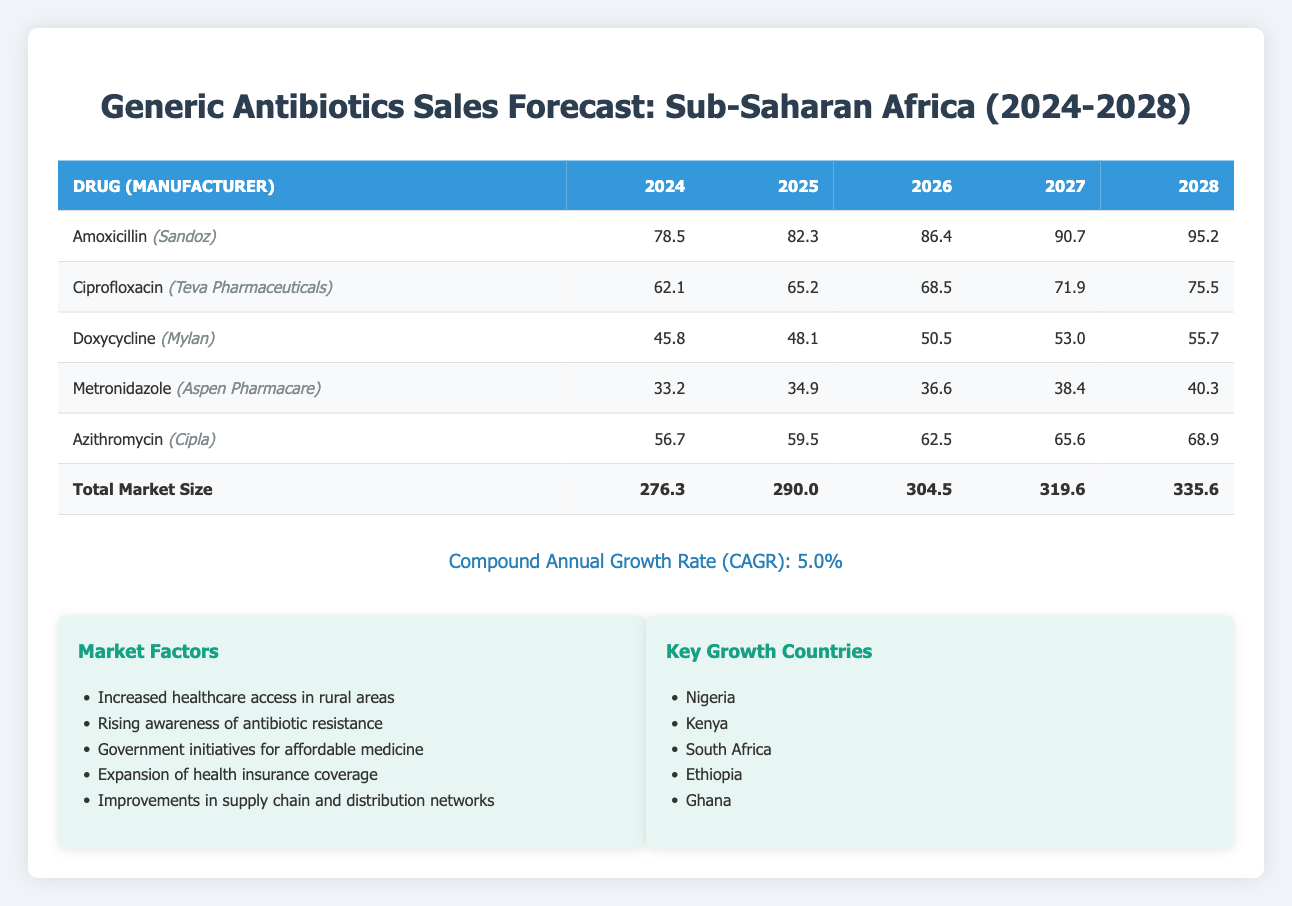What is the total forecast sales for Amoxicillin in 2024? The sales forecast for Amoxicillin in 2024 is listed directly in the table as 78.5 million USD.
Answer: 78.5 million USD Which drug has the highest sales forecast for the year 2026? In 2026, the sales forecasts for all drugs are as follows: Amoxicillin (86.4), Ciprofloxacin (68.5), Doxycycline (50.5), Metronidazole (36.6), and Azithromycin (62.5). The highest is Amoxicillin with sales of 86.4 million USD.
Answer: Amoxicillin What is the percentage increase in total market size from 2024 to 2028? The total market size in 2024 is 276.3 million USD, and in 2028 it is 335.6 million USD. The increase is 335.6 - 276.3 = 59.3 million USD. To find the percentage increase, we divide the increase by the original amount: (59.3 / 276.3) * 100 = 21.4%.
Answer: 21.4% Is the sales forecast for Metronidazole in 2025 greater than the sales forecast for Doxycycline in the same year? The sales forecast for Metronidazole in 2025 is 34.9 million USD, while for Doxycycline it is 48.1 million USD. Since 34.9 is less than 48.1, the statement is false.
Answer: No What is the average annual sales forecast for Ciprofloxacin over the five-year period? The annual sales for Ciprofloxacin over the five years are: 62.1 (2024), 65.2 (2025), 68.5 (2026), 71.9 (2027), 75.5 (2028). The sum is 62.1 + 65.2 + 68.5 + 71.9 + 75.5 = 343.2 million USD. To find the average, we divide by 5: 343.2 / 5 = 68.64 million USD.
Answer: 68.64 million USD Which manufacturer produces Doxycycline? The table indicates that Doxycycline is produced by Mylan.
Answer: Mylan What is the compound annual growth rate (CAGR) of the market size for these antibiotics? The CAGR listed in the table is 5.0%. This represents the annual growth rate over the forecast period from 2024 to 2028.
Answer: 5.0% In which year does Azithromycin reach the highest sales forecast? According to the table, Azithromycin has forecasted sales of 68.9 million USD in 2028, which is the highest sales forecast during the forecast period.
Answer: 2028 